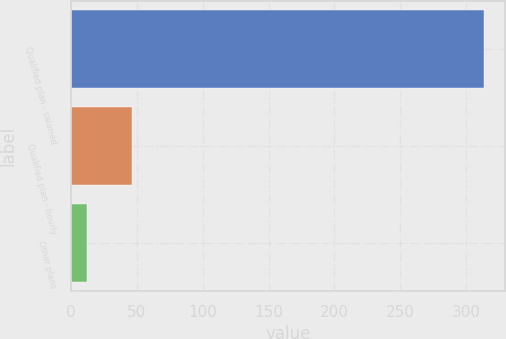Convert chart. <chart><loc_0><loc_0><loc_500><loc_500><bar_chart><fcel>Qualified plan - salaried<fcel>Qualified plan - hourly<fcel>Other plans<nl><fcel>314<fcel>46<fcel>12<nl></chart> 